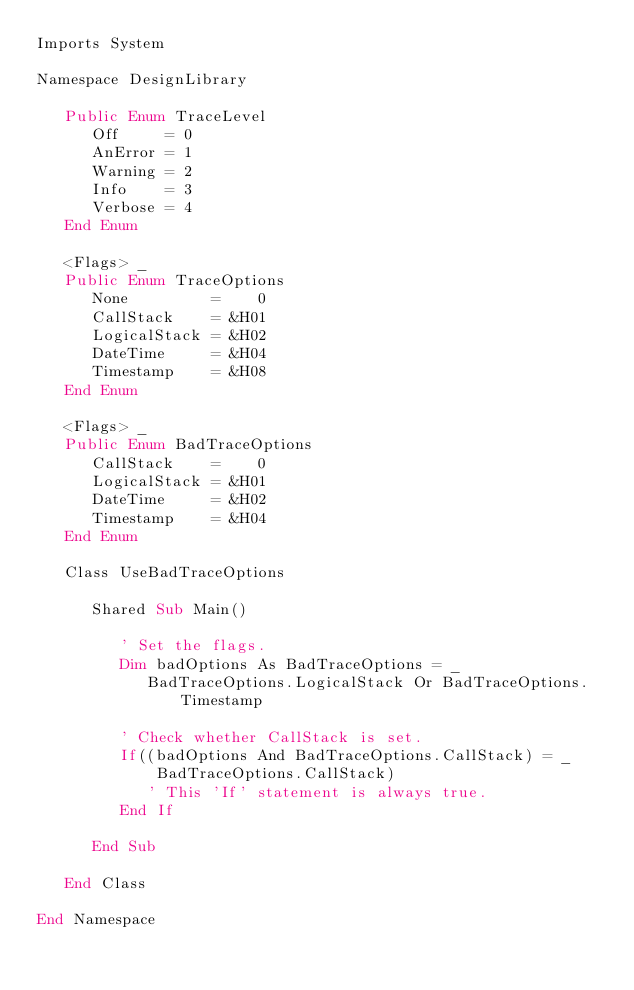<code> <loc_0><loc_0><loc_500><loc_500><_VisualBasic_>Imports System

Namespace DesignLibrary

   Public Enum TraceLevel
      Off     = 0
      AnError = 1
      Warning = 2
      Info    = 3
      Verbose = 4
   End Enum

   <Flags> _
   Public Enum TraceOptions
      None         =    0
      CallStack    = &H01
      LogicalStack = &H02
      DateTime     = &H04
      Timestamp    = &H08
   End Enum

   <Flags> _
   Public Enum BadTraceOptions
      CallStack    =    0
      LogicalStack = &H01
      DateTime     = &H02
      Timestamp    = &H04
   End Enum

   Class UseBadTraceOptions

      Shared Sub Main()

         ' Set the flags.
         Dim badOptions As BadTraceOptions = _
            BadTraceOptions.LogicalStack Or BadTraceOptions.Timestamp

         ' Check whether CallStack is set.
         If((badOptions And BadTraceOptions.CallStack) = _
             BadTraceOptions.CallStack)
            ' This 'If' statement is always true.
         End If

      End Sub
         
   End Class

End Namespace</code> 